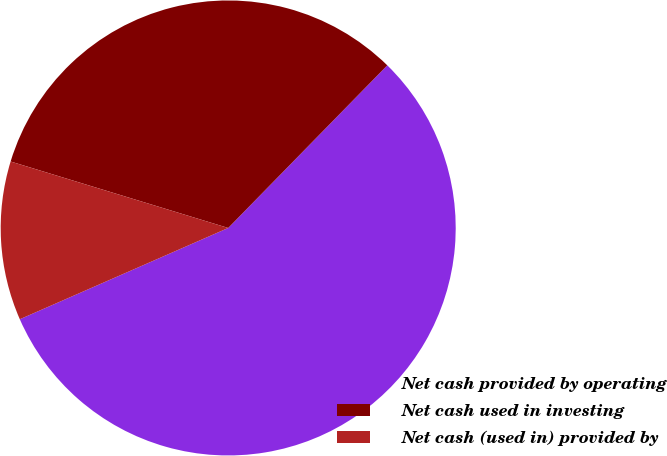<chart> <loc_0><loc_0><loc_500><loc_500><pie_chart><fcel>Net cash provided by operating<fcel>Net cash used in investing<fcel>Net cash (used in) provided by<nl><fcel>56.11%<fcel>32.61%<fcel>11.29%<nl></chart> 